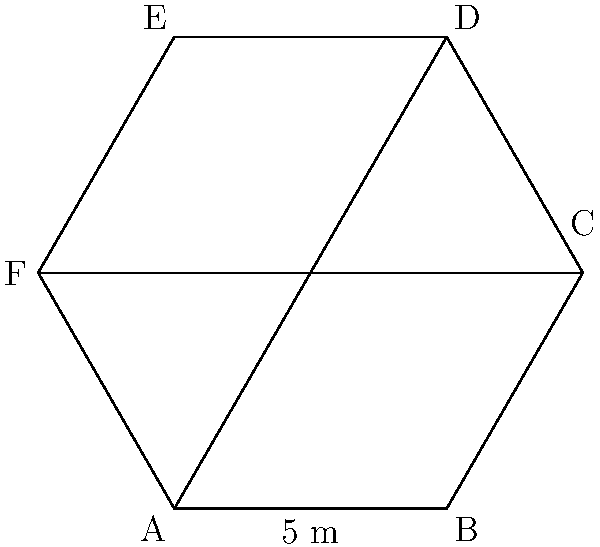As part of your physical therapy, you're designing a hexagonal therapy garden. The garden has equal side lengths of 5 meters. What is the perimeter of the garden? To find the perimeter of the hexagonal therapy garden, we need to follow these steps:

1. Understand the properties of a regular hexagon:
   - A regular hexagon has 6 equal sides
   - All interior angles are equal and measure 120°

2. Identify the given information:
   - Each side of the hexagon is 5 meters long

3. Calculate the perimeter:
   - The perimeter is the sum of all side lengths
   - Since there are 6 sides, and each side is 5 meters long, we can multiply 6 by 5
   - Perimeter = $6 \times 5$ meters

4. Perform the calculation:
   - Perimeter = $6 \times 5 = 30$ meters

Therefore, the perimeter of the hexagonal therapy garden is 30 meters.
Answer: $30$ meters 